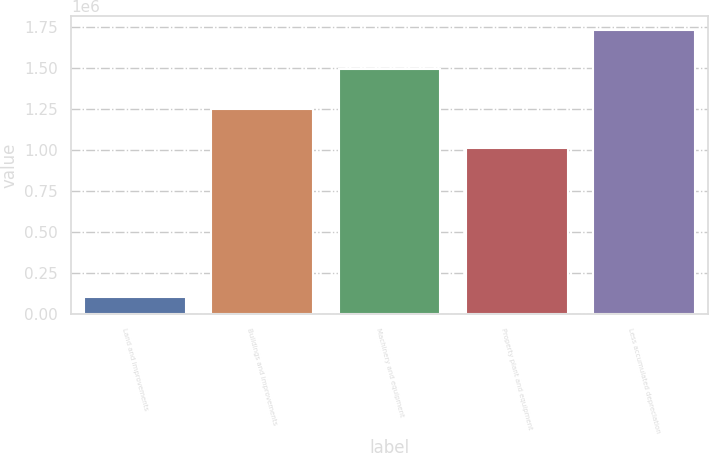Convert chart to OTSL. <chart><loc_0><loc_0><loc_500><loc_500><bar_chart><fcel>Land and improvements<fcel>Buildings and improvements<fcel>Machinery and equipment<fcel>Property plant and equipment<fcel>Less accumulated depreciation<nl><fcel>104257<fcel>1.25316e+06<fcel>1.49169e+06<fcel>1.01464e+06<fcel>1.73022e+06<nl></chart> 